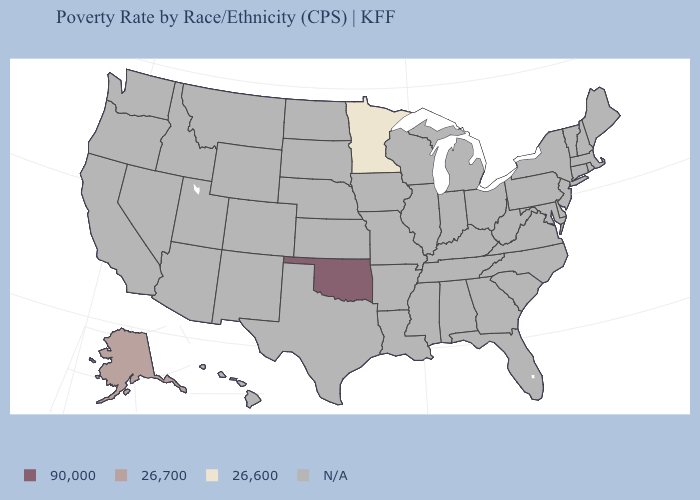What is the value of Vermont?
Short answer required. N/A. Does Minnesota have the highest value in the USA?
Be succinct. No. What is the value of Arkansas?
Concise answer only. N/A. What is the value of Kansas?
Give a very brief answer. N/A. Name the states that have a value in the range N/A?
Quick response, please. Alabama, Arizona, Arkansas, California, Colorado, Connecticut, Delaware, Florida, Georgia, Hawaii, Idaho, Illinois, Indiana, Iowa, Kansas, Kentucky, Louisiana, Maine, Maryland, Massachusetts, Michigan, Mississippi, Missouri, Montana, Nebraska, Nevada, New Hampshire, New Jersey, New Mexico, New York, North Carolina, North Dakota, Ohio, Oregon, Pennsylvania, Rhode Island, South Carolina, South Dakota, Tennessee, Texas, Utah, Vermont, Virginia, Washington, West Virginia, Wisconsin, Wyoming. Is the legend a continuous bar?
Concise answer only. No. What is the value of Washington?
Write a very short answer. N/A. Name the states that have a value in the range 26,700?
Concise answer only. Alaska. What is the value of Louisiana?
Give a very brief answer. N/A. Name the states that have a value in the range 26,600?
Keep it brief. Minnesota. Does the first symbol in the legend represent the smallest category?
Be succinct. No. 